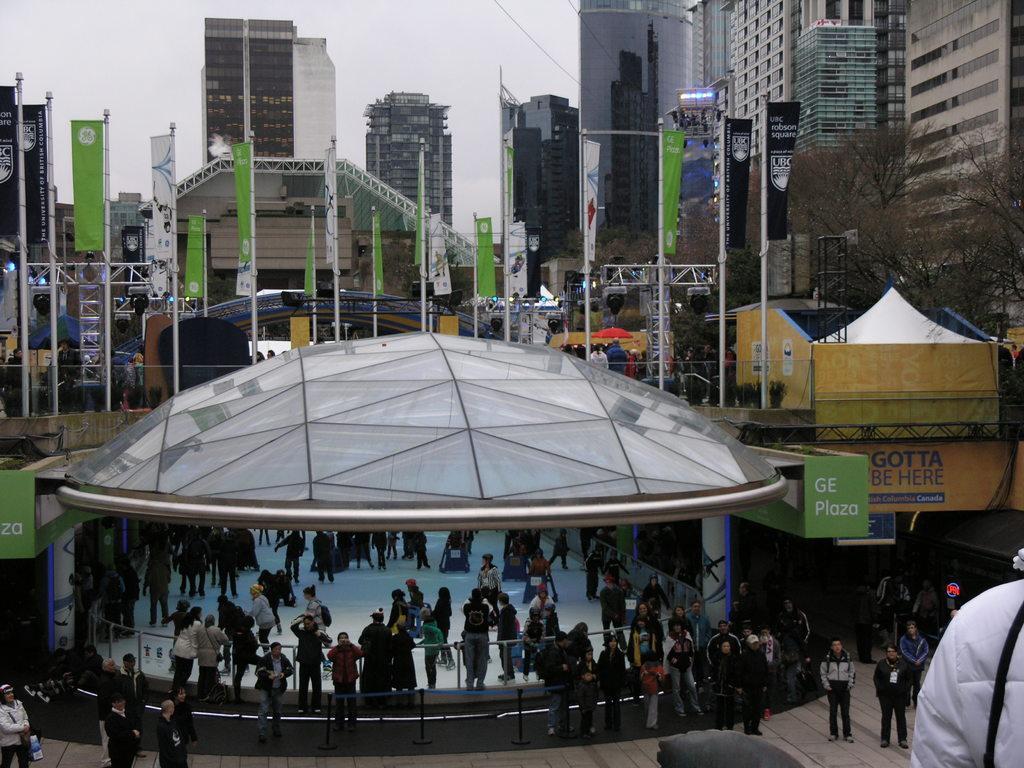Please provide a concise description of this image. The picture is taken outside a city. In the foreground of the picture there are people and various buildings. In the center of the picture there are trees, banners, poles and various objects. In the background there are buildings. 